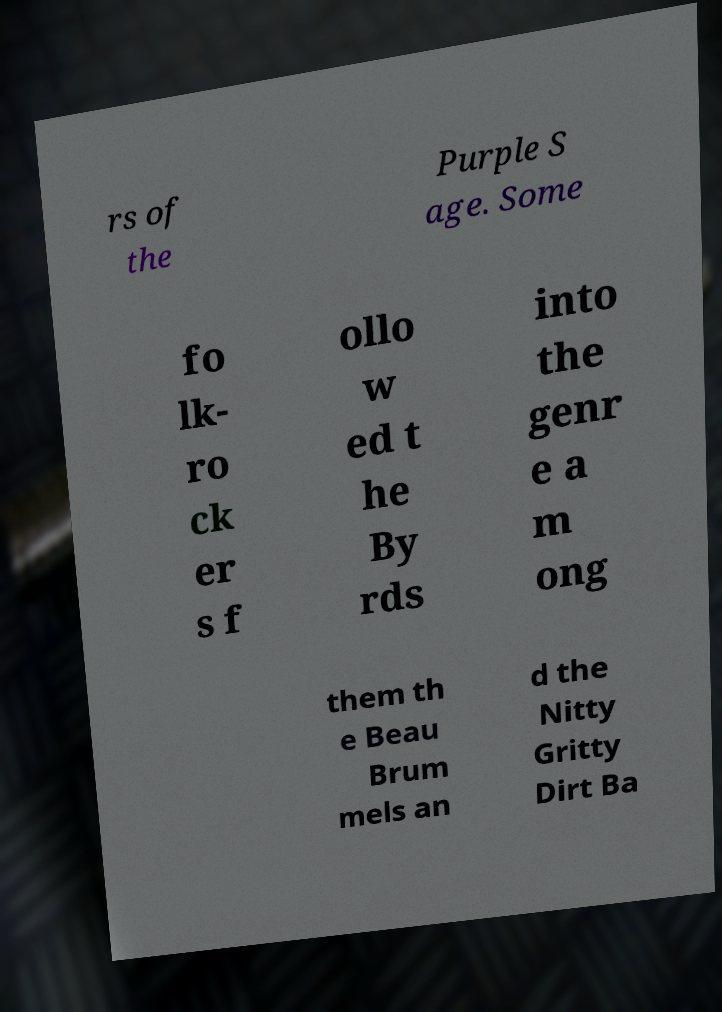Please read and relay the text visible in this image. What does it say? rs of the Purple S age. Some fo lk- ro ck er s f ollo w ed t he By rds into the genr e a m ong them th e Beau Brum mels an d the Nitty Gritty Dirt Ba 